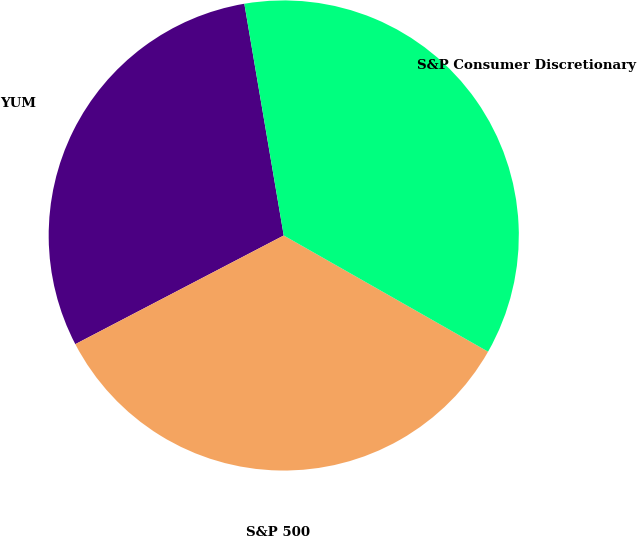<chart> <loc_0><loc_0><loc_500><loc_500><pie_chart><fcel>YUM<fcel>S&P 500<fcel>S&P Consumer Discretionary<nl><fcel>29.97%<fcel>34.12%<fcel>35.91%<nl></chart> 